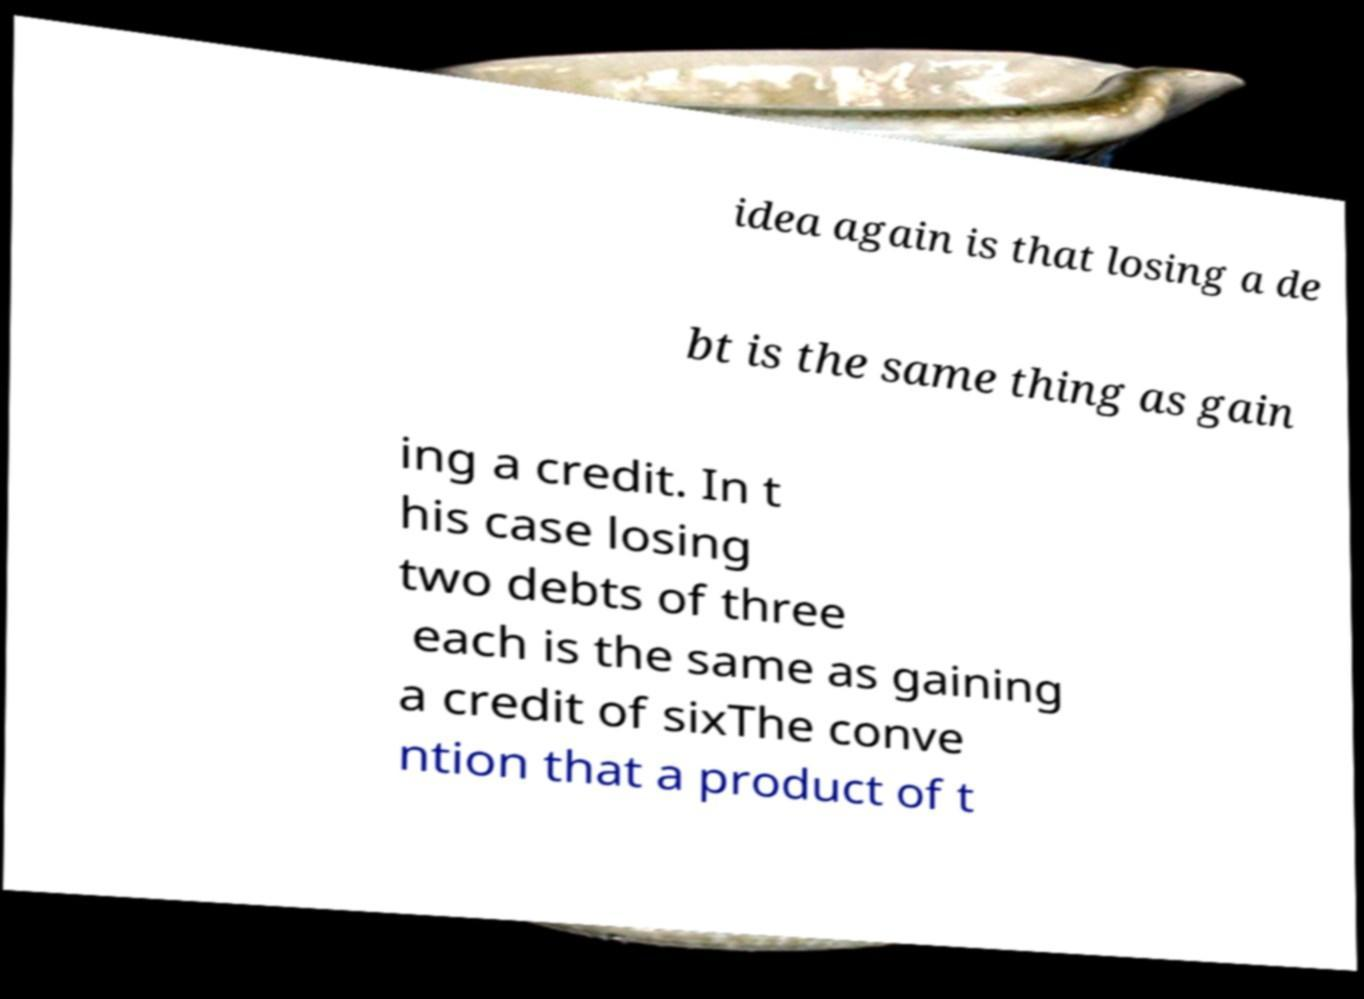Please identify and transcribe the text found in this image. idea again is that losing a de bt is the same thing as gain ing a credit. In t his case losing two debts of three each is the same as gaining a credit of sixThe conve ntion that a product of t 